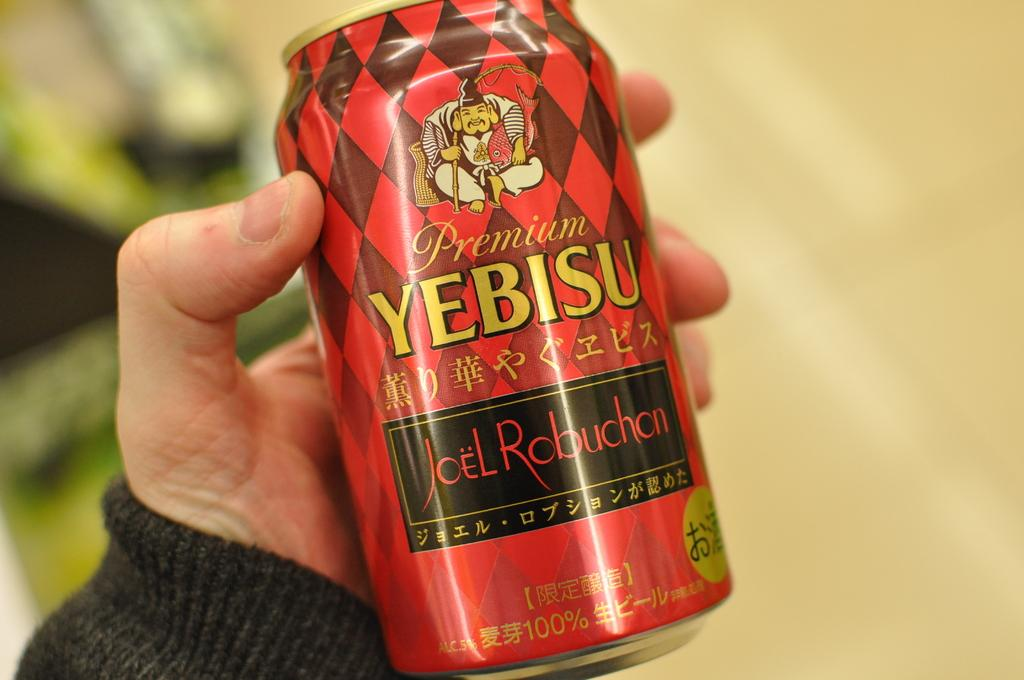<image>
Describe the image concisely. a red and black diamond can of yebisu beer 